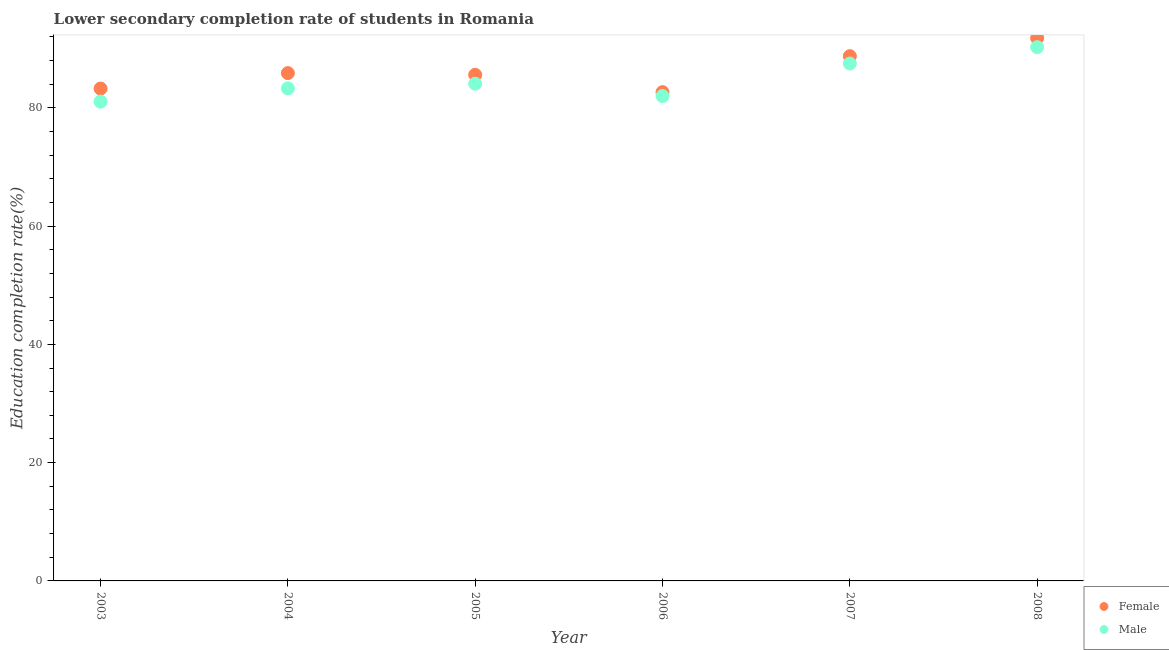How many different coloured dotlines are there?
Offer a very short reply. 2. Is the number of dotlines equal to the number of legend labels?
Provide a succinct answer. Yes. What is the education completion rate of male students in 2007?
Ensure brevity in your answer.  87.49. Across all years, what is the maximum education completion rate of male students?
Your answer should be compact. 90.26. Across all years, what is the minimum education completion rate of male students?
Ensure brevity in your answer.  81.05. In which year was the education completion rate of male students maximum?
Provide a short and direct response. 2008. In which year was the education completion rate of female students minimum?
Ensure brevity in your answer.  2006. What is the total education completion rate of female students in the graph?
Your response must be concise. 517.91. What is the difference between the education completion rate of male students in 2005 and that in 2008?
Offer a terse response. -6.18. What is the difference between the education completion rate of female students in 2003 and the education completion rate of male students in 2004?
Your answer should be very brief. -0.03. What is the average education completion rate of male students per year?
Your answer should be compact. 84.69. In the year 2005, what is the difference between the education completion rate of male students and education completion rate of female students?
Offer a terse response. -1.5. What is the ratio of the education completion rate of female students in 2004 to that in 2008?
Make the answer very short. 0.94. Is the education completion rate of female students in 2005 less than that in 2008?
Make the answer very short. Yes. What is the difference between the highest and the second highest education completion rate of male students?
Your answer should be very brief. 2.77. What is the difference between the highest and the lowest education completion rate of female students?
Your answer should be compact. 9.15. Is the sum of the education completion rate of male students in 2004 and 2005 greater than the maximum education completion rate of female students across all years?
Your answer should be compact. Yes. Does the education completion rate of female students monotonically increase over the years?
Offer a very short reply. No. Is the education completion rate of male students strictly greater than the education completion rate of female students over the years?
Your answer should be very brief. No. Does the graph contain any zero values?
Provide a succinct answer. No. Does the graph contain grids?
Your response must be concise. No. How many legend labels are there?
Ensure brevity in your answer.  2. What is the title of the graph?
Your answer should be compact. Lower secondary completion rate of students in Romania. Does "Resident" appear as one of the legend labels in the graph?
Give a very brief answer. No. What is the label or title of the X-axis?
Keep it short and to the point. Year. What is the label or title of the Y-axis?
Your response must be concise. Education completion rate(%). What is the Education completion rate(%) of Female in 2003?
Provide a succinct answer. 83.26. What is the Education completion rate(%) in Male in 2003?
Offer a very short reply. 81.05. What is the Education completion rate(%) in Female in 2004?
Provide a succinct answer. 85.88. What is the Education completion rate(%) in Male in 2004?
Keep it short and to the point. 83.29. What is the Education completion rate(%) of Female in 2005?
Offer a very short reply. 85.59. What is the Education completion rate(%) of Male in 2005?
Offer a terse response. 84.08. What is the Education completion rate(%) of Female in 2006?
Make the answer very short. 82.65. What is the Education completion rate(%) in Male in 2006?
Offer a terse response. 81.99. What is the Education completion rate(%) of Female in 2007?
Make the answer very short. 88.74. What is the Education completion rate(%) of Male in 2007?
Provide a succinct answer. 87.49. What is the Education completion rate(%) of Female in 2008?
Keep it short and to the point. 91.8. What is the Education completion rate(%) of Male in 2008?
Provide a succinct answer. 90.26. Across all years, what is the maximum Education completion rate(%) in Female?
Your response must be concise. 91.8. Across all years, what is the maximum Education completion rate(%) in Male?
Your response must be concise. 90.26. Across all years, what is the minimum Education completion rate(%) in Female?
Make the answer very short. 82.65. Across all years, what is the minimum Education completion rate(%) of Male?
Give a very brief answer. 81.05. What is the total Education completion rate(%) in Female in the graph?
Your answer should be very brief. 517.91. What is the total Education completion rate(%) in Male in the graph?
Provide a short and direct response. 508.16. What is the difference between the Education completion rate(%) of Female in 2003 and that in 2004?
Make the answer very short. -2.62. What is the difference between the Education completion rate(%) in Male in 2003 and that in 2004?
Provide a short and direct response. -2.24. What is the difference between the Education completion rate(%) in Female in 2003 and that in 2005?
Provide a short and direct response. -2.33. What is the difference between the Education completion rate(%) in Male in 2003 and that in 2005?
Your answer should be compact. -3.03. What is the difference between the Education completion rate(%) in Female in 2003 and that in 2006?
Your response must be concise. 0.6. What is the difference between the Education completion rate(%) of Male in 2003 and that in 2006?
Your answer should be compact. -0.94. What is the difference between the Education completion rate(%) of Female in 2003 and that in 2007?
Keep it short and to the point. -5.48. What is the difference between the Education completion rate(%) in Male in 2003 and that in 2007?
Offer a terse response. -6.44. What is the difference between the Education completion rate(%) in Female in 2003 and that in 2008?
Provide a short and direct response. -8.54. What is the difference between the Education completion rate(%) of Male in 2003 and that in 2008?
Make the answer very short. -9.21. What is the difference between the Education completion rate(%) in Female in 2004 and that in 2005?
Make the answer very short. 0.29. What is the difference between the Education completion rate(%) of Male in 2004 and that in 2005?
Provide a short and direct response. -0.79. What is the difference between the Education completion rate(%) in Female in 2004 and that in 2006?
Your response must be concise. 3.22. What is the difference between the Education completion rate(%) in Male in 2004 and that in 2006?
Give a very brief answer. 1.3. What is the difference between the Education completion rate(%) in Female in 2004 and that in 2007?
Your answer should be very brief. -2.87. What is the difference between the Education completion rate(%) in Male in 2004 and that in 2007?
Ensure brevity in your answer.  -4.2. What is the difference between the Education completion rate(%) in Female in 2004 and that in 2008?
Provide a short and direct response. -5.92. What is the difference between the Education completion rate(%) in Male in 2004 and that in 2008?
Give a very brief answer. -6.97. What is the difference between the Education completion rate(%) in Female in 2005 and that in 2006?
Your response must be concise. 2.93. What is the difference between the Education completion rate(%) in Male in 2005 and that in 2006?
Give a very brief answer. 2.09. What is the difference between the Education completion rate(%) of Female in 2005 and that in 2007?
Offer a terse response. -3.16. What is the difference between the Education completion rate(%) of Male in 2005 and that in 2007?
Your response must be concise. -3.41. What is the difference between the Education completion rate(%) in Female in 2005 and that in 2008?
Keep it short and to the point. -6.21. What is the difference between the Education completion rate(%) of Male in 2005 and that in 2008?
Offer a terse response. -6.18. What is the difference between the Education completion rate(%) in Female in 2006 and that in 2007?
Your response must be concise. -6.09. What is the difference between the Education completion rate(%) of Male in 2006 and that in 2007?
Offer a terse response. -5.5. What is the difference between the Education completion rate(%) of Female in 2006 and that in 2008?
Keep it short and to the point. -9.15. What is the difference between the Education completion rate(%) in Male in 2006 and that in 2008?
Keep it short and to the point. -8.26. What is the difference between the Education completion rate(%) in Female in 2007 and that in 2008?
Make the answer very short. -3.06. What is the difference between the Education completion rate(%) in Male in 2007 and that in 2008?
Your response must be concise. -2.77. What is the difference between the Education completion rate(%) in Female in 2003 and the Education completion rate(%) in Male in 2004?
Offer a terse response. -0.03. What is the difference between the Education completion rate(%) in Female in 2003 and the Education completion rate(%) in Male in 2005?
Give a very brief answer. -0.82. What is the difference between the Education completion rate(%) of Female in 2003 and the Education completion rate(%) of Male in 2006?
Ensure brevity in your answer.  1.26. What is the difference between the Education completion rate(%) of Female in 2003 and the Education completion rate(%) of Male in 2007?
Offer a very short reply. -4.23. What is the difference between the Education completion rate(%) in Female in 2003 and the Education completion rate(%) in Male in 2008?
Offer a terse response. -7. What is the difference between the Education completion rate(%) in Female in 2004 and the Education completion rate(%) in Male in 2005?
Give a very brief answer. 1.79. What is the difference between the Education completion rate(%) in Female in 2004 and the Education completion rate(%) in Male in 2006?
Make the answer very short. 3.88. What is the difference between the Education completion rate(%) in Female in 2004 and the Education completion rate(%) in Male in 2007?
Offer a very short reply. -1.61. What is the difference between the Education completion rate(%) in Female in 2004 and the Education completion rate(%) in Male in 2008?
Provide a succinct answer. -4.38. What is the difference between the Education completion rate(%) of Female in 2005 and the Education completion rate(%) of Male in 2006?
Provide a succinct answer. 3.59. What is the difference between the Education completion rate(%) in Female in 2005 and the Education completion rate(%) in Male in 2007?
Give a very brief answer. -1.9. What is the difference between the Education completion rate(%) of Female in 2005 and the Education completion rate(%) of Male in 2008?
Give a very brief answer. -4.67. What is the difference between the Education completion rate(%) of Female in 2006 and the Education completion rate(%) of Male in 2007?
Give a very brief answer. -4.84. What is the difference between the Education completion rate(%) of Female in 2006 and the Education completion rate(%) of Male in 2008?
Make the answer very short. -7.6. What is the difference between the Education completion rate(%) in Female in 2007 and the Education completion rate(%) in Male in 2008?
Offer a very short reply. -1.52. What is the average Education completion rate(%) in Female per year?
Offer a very short reply. 86.32. What is the average Education completion rate(%) of Male per year?
Offer a terse response. 84.69. In the year 2003, what is the difference between the Education completion rate(%) in Female and Education completion rate(%) in Male?
Your answer should be compact. 2.21. In the year 2004, what is the difference between the Education completion rate(%) in Female and Education completion rate(%) in Male?
Provide a short and direct response. 2.58. In the year 2005, what is the difference between the Education completion rate(%) in Female and Education completion rate(%) in Male?
Your answer should be very brief. 1.5. In the year 2006, what is the difference between the Education completion rate(%) of Female and Education completion rate(%) of Male?
Provide a short and direct response. 0.66. In the year 2007, what is the difference between the Education completion rate(%) in Female and Education completion rate(%) in Male?
Offer a terse response. 1.25. In the year 2008, what is the difference between the Education completion rate(%) in Female and Education completion rate(%) in Male?
Give a very brief answer. 1.54. What is the ratio of the Education completion rate(%) of Female in 2003 to that in 2004?
Ensure brevity in your answer.  0.97. What is the ratio of the Education completion rate(%) in Male in 2003 to that in 2004?
Give a very brief answer. 0.97. What is the ratio of the Education completion rate(%) of Female in 2003 to that in 2005?
Offer a terse response. 0.97. What is the ratio of the Education completion rate(%) in Male in 2003 to that in 2005?
Offer a very short reply. 0.96. What is the ratio of the Education completion rate(%) of Female in 2003 to that in 2006?
Ensure brevity in your answer.  1.01. What is the ratio of the Education completion rate(%) of Male in 2003 to that in 2006?
Provide a succinct answer. 0.99. What is the ratio of the Education completion rate(%) in Female in 2003 to that in 2007?
Keep it short and to the point. 0.94. What is the ratio of the Education completion rate(%) in Male in 2003 to that in 2007?
Your answer should be compact. 0.93. What is the ratio of the Education completion rate(%) in Female in 2003 to that in 2008?
Keep it short and to the point. 0.91. What is the ratio of the Education completion rate(%) of Male in 2003 to that in 2008?
Make the answer very short. 0.9. What is the ratio of the Education completion rate(%) of Female in 2004 to that in 2005?
Offer a terse response. 1. What is the ratio of the Education completion rate(%) in Male in 2004 to that in 2005?
Give a very brief answer. 0.99. What is the ratio of the Education completion rate(%) in Female in 2004 to that in 2006?
Offer a terse response. 1.04. What is the ratio of the Education completion rate(%) in Male in 2004 to that in 2006?
Your answer should be very brief. 1.02. What is the ratio of the Education completion rate(%) in Female in 2004 to that in 2007?
Ensure brevity in your answer.  0.97. What is the ratio of the Education completion rate(%) in Male in 2004 to that in 2007?
Your answer should be compact. 0.95. What is the ratio of the Education completion rate(%) of Female in 2004 to that in 2008?
Provide a succinct answer. 0.94. What is the ratio of the Education completion rate(%) of Male in 2004 to that in 2008?
Provide a short and direct response. 0.92. What is the ratio of the Education completion rate(%) of Female in 2005 to that in 2006?
Offer a very short reply. 1.04. What is the ratio of the Education completion rate(%) in Male in 2005 to that in 2006?
Your answer should be compact. 1.03. What is the ratio of the Education completion rate(%) in Female in 2005 to that in 2007?
Give a very brief answer. 0.96. What is the ratio of the Education completion rate(%) in Male in 2005 to that in 2007?
Provide a succinct answer. 0.96. What is the ratio of the Education completion rate(%) in Female in 2005 to that in 2008?
Your answer should be compact. 0.93. What is the ratio of the Education completion rate(%) of Male in 2005 to that in 2008?
Your answer should be compact. 0.93. What is the ratio of the Education completion rate(%) of Female in 2006 to that in 2007?
Provide a short and direct response. 0.93. What is the ratio of the Education completion rate(%) in Male in 2006 to that in 2007?
Ensure brevity in your answer.  0.94. What is the ratio of the Education completion rate(%) of Female in 2006 to that in 2008?
Ensure brevity in your answer.  0.9. What is the ratio of the Education completion rate(%) of Male in 2006 to that in 2008?
Offer a very short reply. 0.91. What is the ratio of the Education completion rate(%) in Female in 2007 to that in 2008?
Keep it short and to the point. 0.97. What is the ratio of the Education completion rate(%) in Male in 2007 to that in 2008?
Your answer should be very brief. 0.97. What is the difference between the highest and the second highest Education completion rate(%) of Female?
Your response must be concise. 3.06. What is the difference between the highest and the second highest Education completion rate(%) of Male?
Provide a short and direct response. 2.77. What is the difference between the highest and the lowest Education completion rate(%) of Female?
Your answer should be very brief. 9.15. What is the difference between the highest and the lowest Education completion rate(%) of Male?
Offer a terse response. 9.21. 